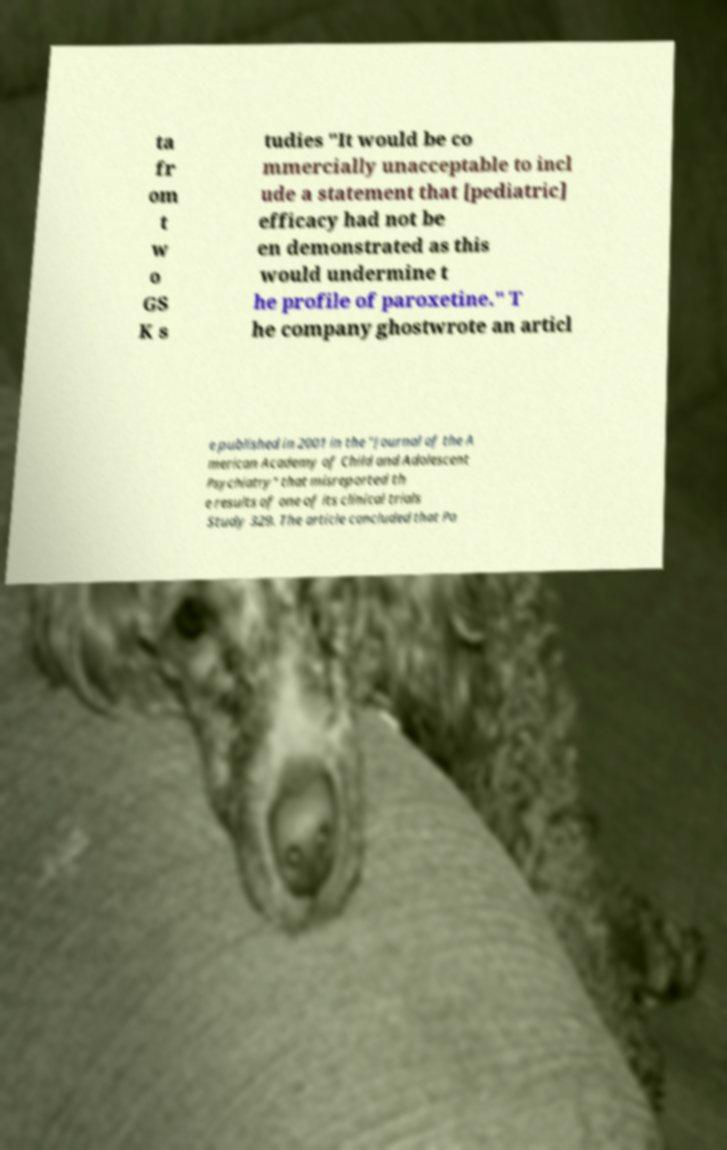Can you read and provide the text displayed in the image?This photo seems to have some interesting text. Can you extract and type it out for me? ta fr om t w o GS K s tudies "It would be co mmercially unacceptable to incl ude a statement that [pediatric] efficacy had not be en demonstrated as this would undermine t he profile of paroxetine." T he company ghostwrote an articl e published in 2001 in the "Journal of the A merican Academy of Child and Adolescent Psychiatry" that misreported th e results of one of its clinical trials Study 329. The article concluded that Pa 